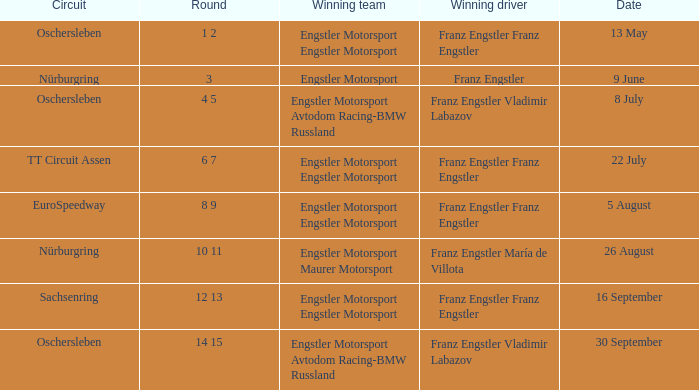What Round was the Winning Team Engstler Motorsport Maurer Motorsport? 10 11. 